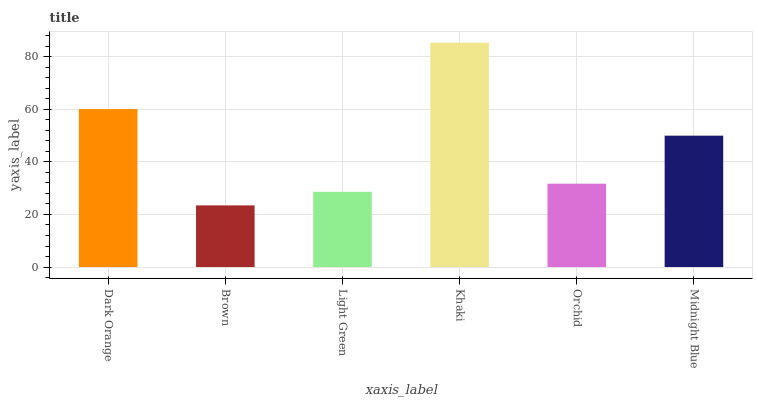Is Brown the minimum?
Answer yes or no. Yes. Is Khaki the maximum?
Answer yes or no. Yes. Is Light Green the minimum?
Answer yes or no. No. Is Light Green the maximum?
Answer yes or no. No. Is Light Green greater than Brown?
Answer yes or no. Yes. Is Brown less than Light Green?
Answer yes or no. Yes. Is Brown greater than Light Green?
Answer yes or no. No. Is Light Green less than Brown?
Answer yes or no. No. Is Midnight Blue the high median?
Answer yes or no. Yes. Is Orchid the low median?
Answer yes or no. Yes. Is Orchid the high median?
Answer yes or no. No. Is Brown the low median?
Answer yes or no. No. 